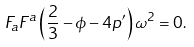<formula> <loc_0><loc_0><loc_500><loc_500>F _ { a } F ^ { a } \left ( \frac { 2 } { 3 } - \phi - 4 p ^ { \prime } \right ) \omega ^ { 2 } = 0 .</formula> 